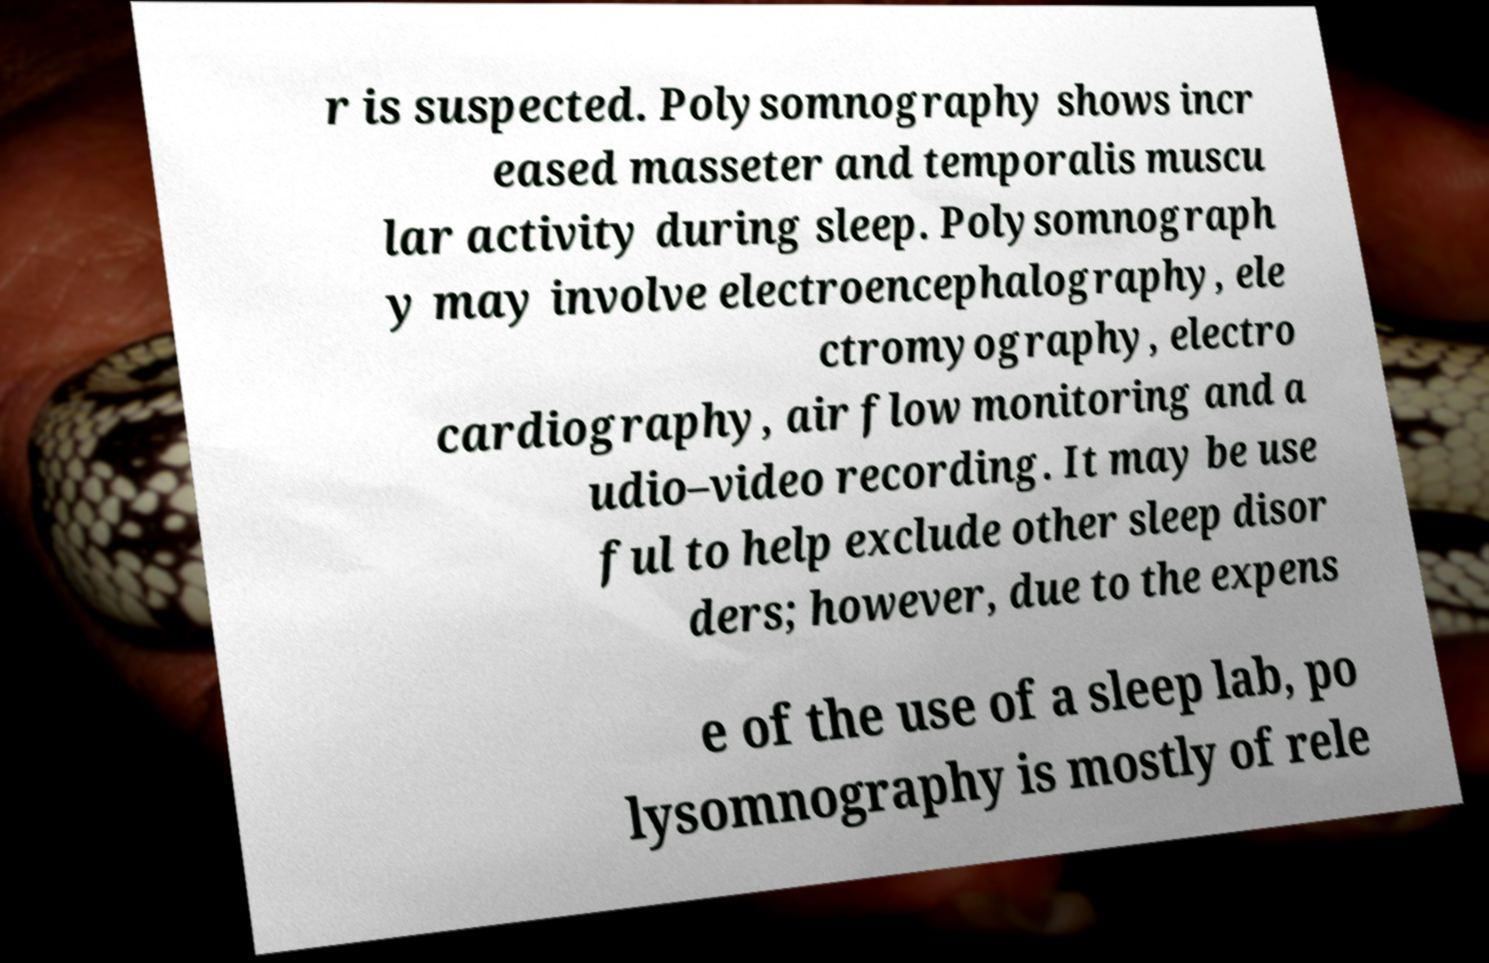Could you assist in decoding the text presented in this image and type it out clearly? r is suspected. Polysomnography shows incr eased masseter and temporalis muscu lar activity during sleep. Polysomnograph y may involve electroencephalography, ele ctromyography, electro cardiography, air flow monitoring and a udio–video recording. It may be use ful to help exclude other sleep disor ders; however, due to the expens e of the use of a sleep lab, po lysomnography is mostly of rele 